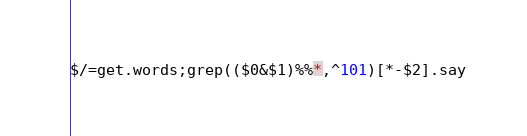<code> <loc_0><loc_0><loc_500><loc_500><_Perl_>$/=get.words;grep(($0&$1)%%*,^101)[*-$2].say</code> 